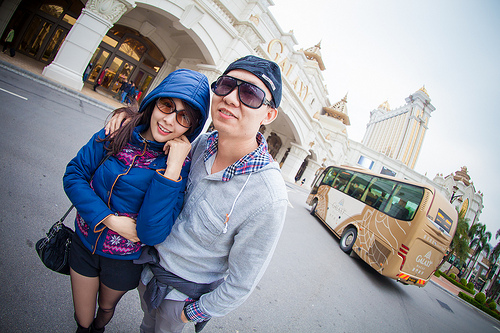<image>
Can you confirm if the bus is behind the man? Yes. From this viewpoint, the bus is positioned behind the man, with the man partially or fully occluding the bus. Where is the man in relation to the bus? Is it behind the bus? No. The man is not behind the bus. From this viewpoint, the man appears to be positioned elsewhere in the scene. 